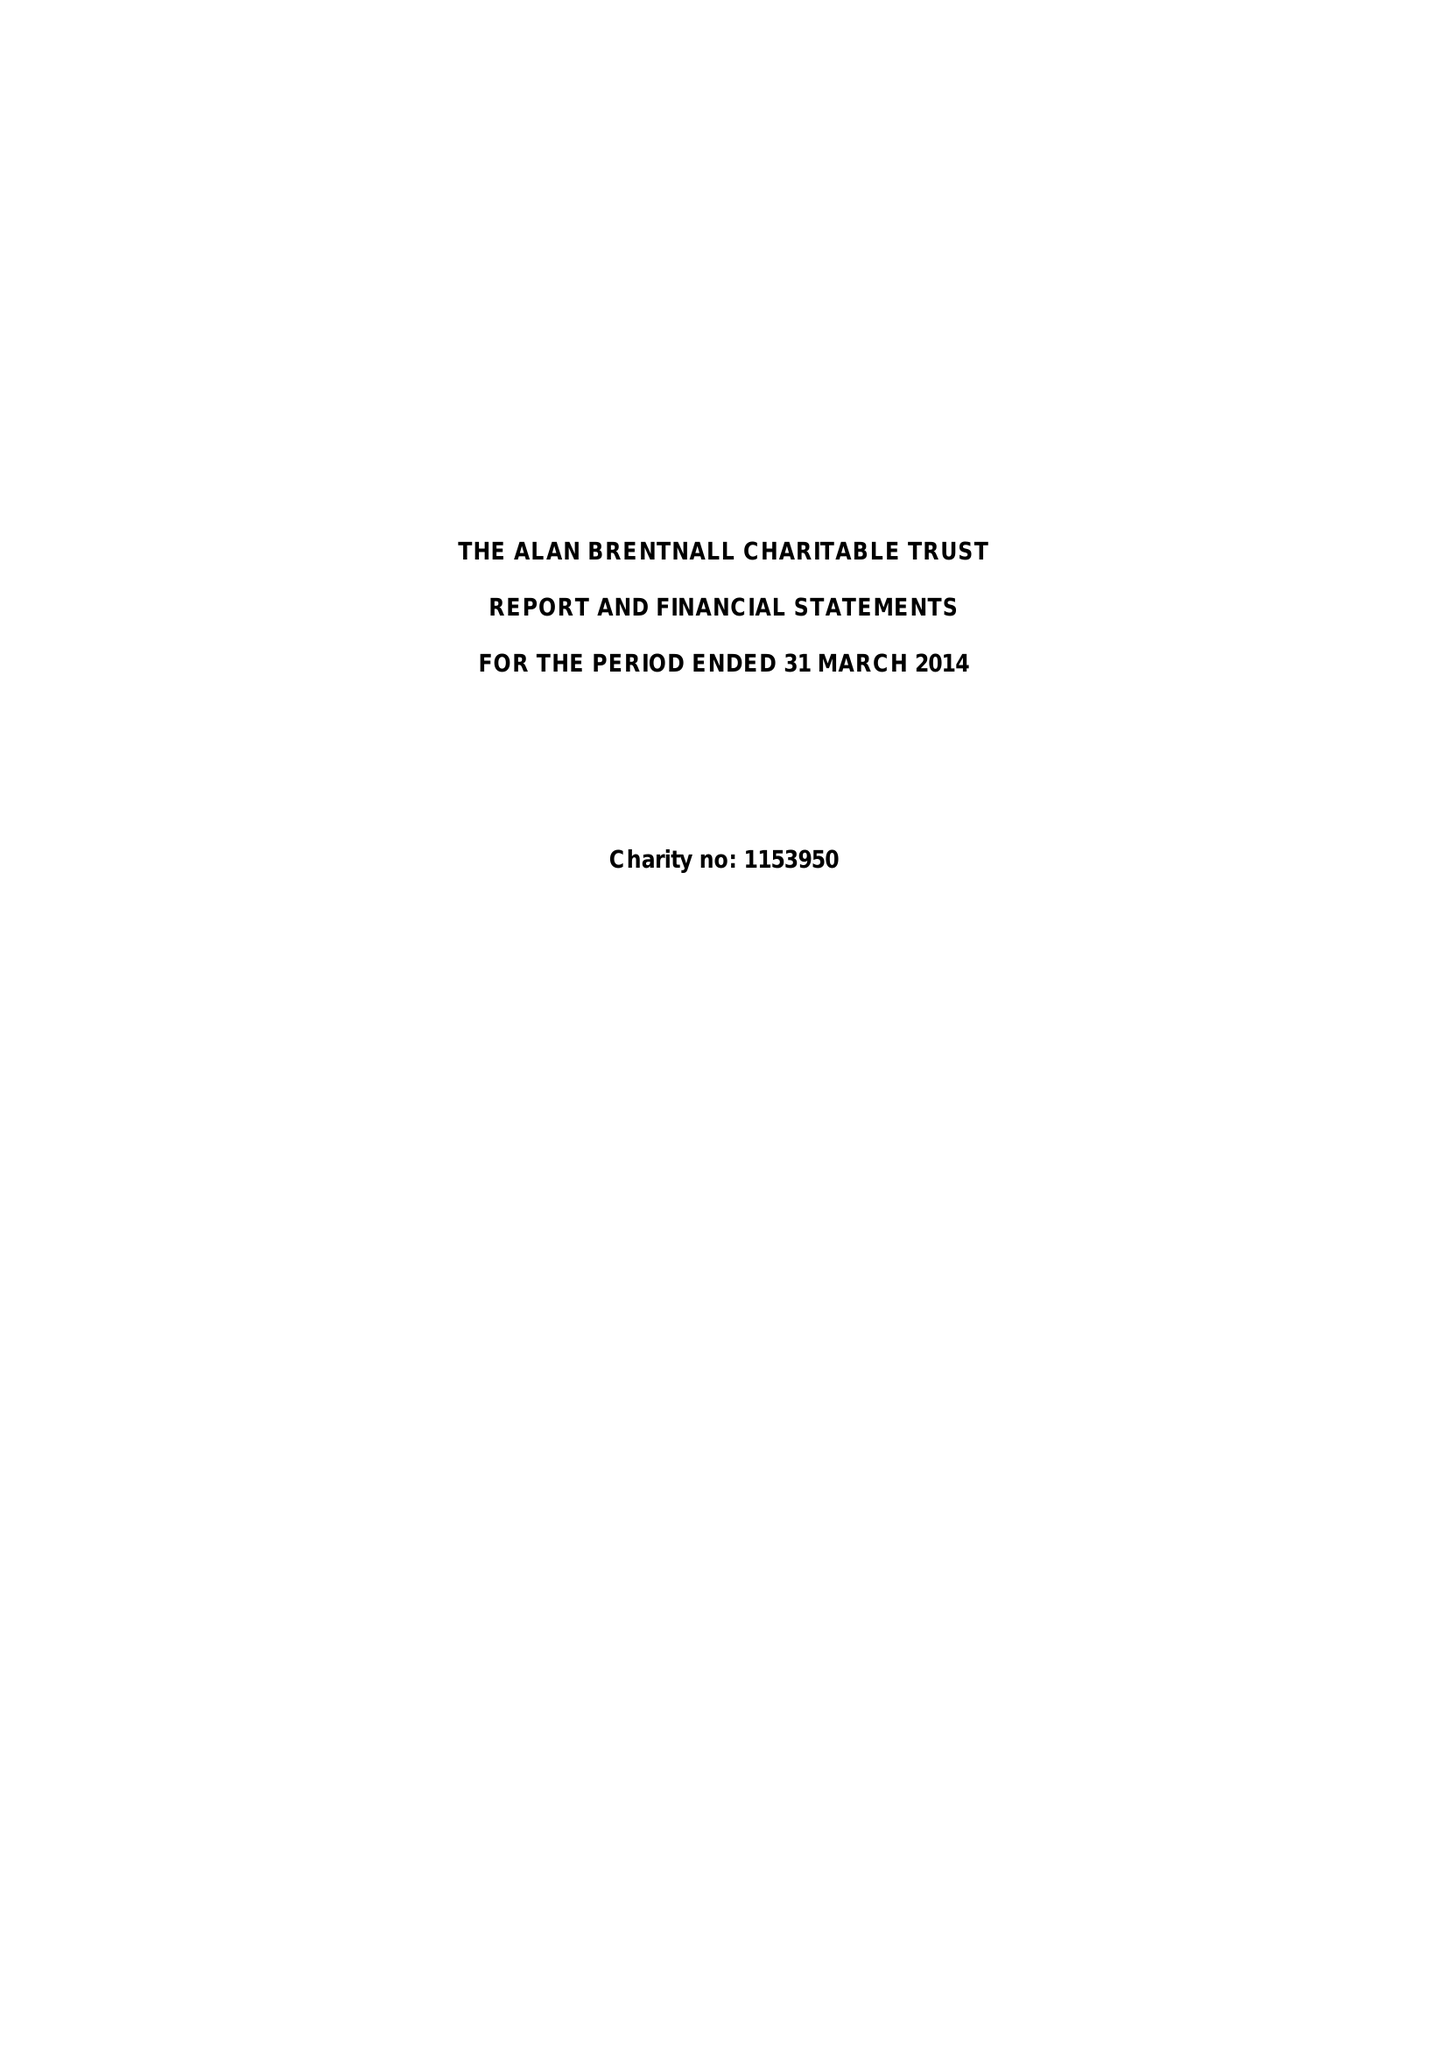What is the value for the report_date?
Answer the question using a single word or phrase. 2014-03-31 